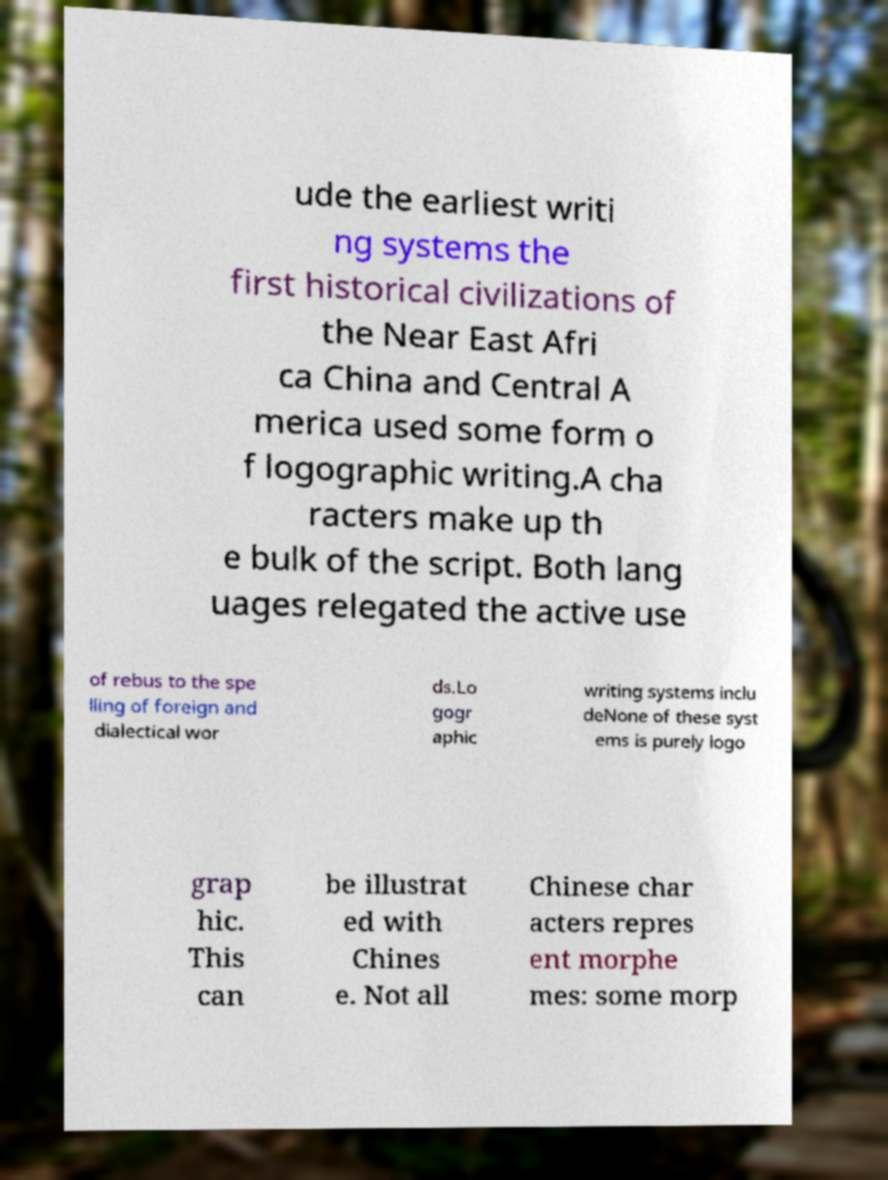Could you assist in decoding the text presented in this image and type it out clearly? ude the earliest writi ng systems the first historical civilizations of the Near East Afri ca China and Central A merica used some form o f logographic writing.A cha racters make up th e bulk of the script. Both lang uages relegated the active use of rebus to the spe lling of foreign and dialectical wor ds.Lo gogr aphic writing systems inclu deNone of these syst ems is purely logo grap hic. This can be illustrat ed with Chines e. Not all Chinese char acters repres ent morphe mes: some morp 